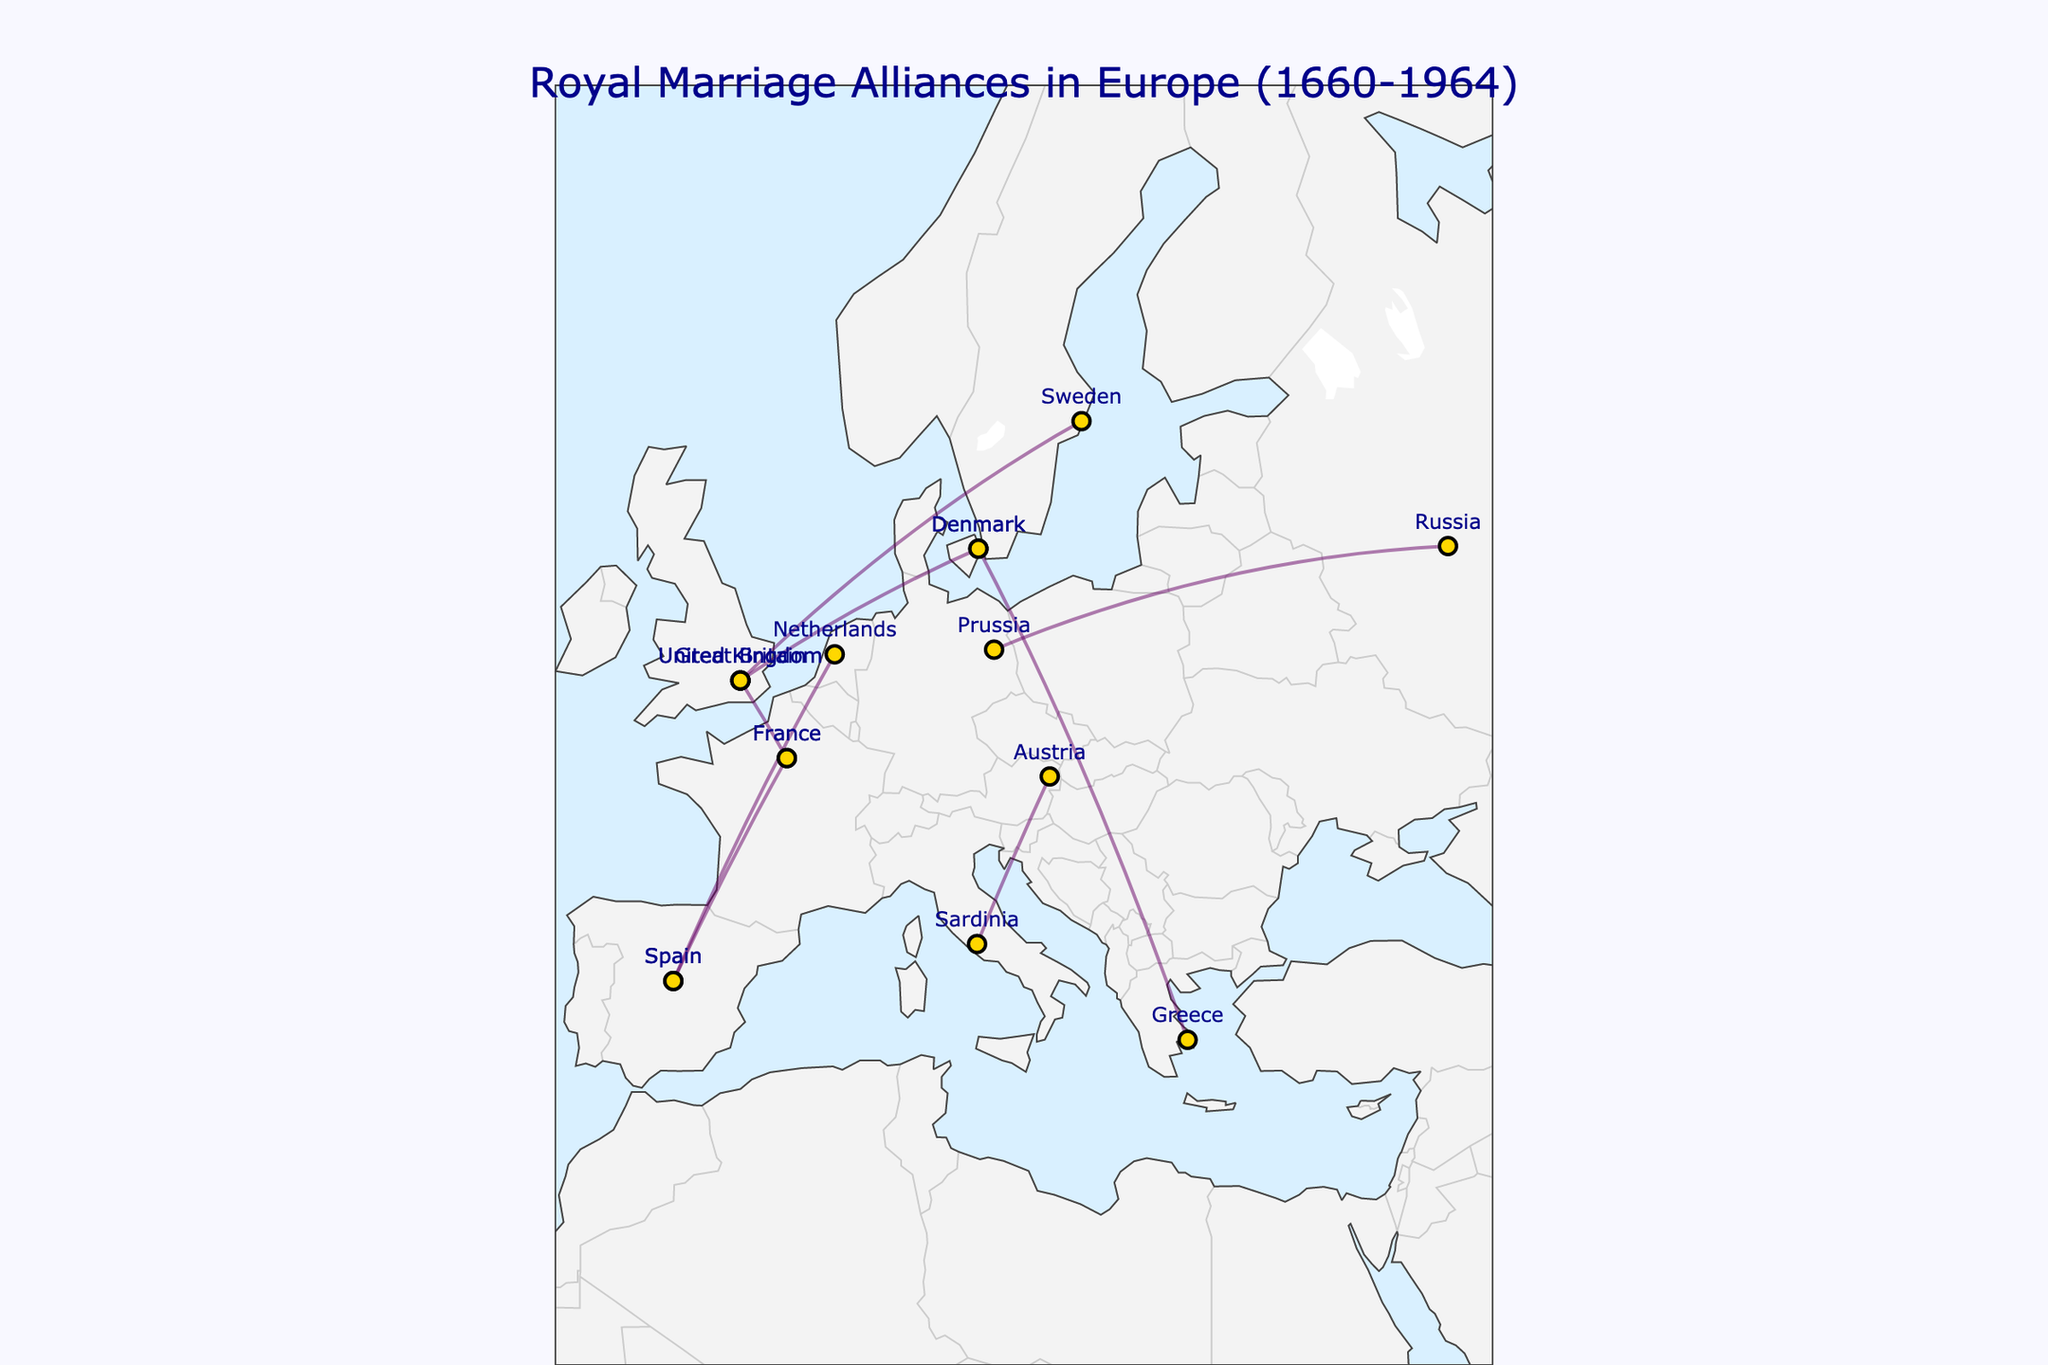What is the title of the plot? The title can be found at the top of the plot, usually in large font and centered.
Answer: Royal Marriage Alliances in Europe (1660-1964) What is the color of the lines representing royal marriages? The color of the lines can be seen by looking at the paths connecting different points on the plot.
Answer: Purple Which two dynasties were connected by a marriage in 1766? Look for the hover text or the lines indicating the marriages.
Answer: Hanover and Oldenburg Which country has the highest number of royal marriage connections represented in this plot? Count how many times each country appears in the plot.
Answer: United Kingdom What is the latitude and longitude range displayed on the plot? Check the labels on the axes or the bounding box of the plot's geographic area.
Answer: Latitude: 30 to 70, Longitude: -10 to 40 Which royal marriage is represented between dynasties from Sweden and the United Kingdom? Look for the line connecting the locations of Sweden and the United Kingdom and verify the hover text.
Answer: Bernadotte and Battenberg How many royal marriages involved France as one of the countries? Count the number of lines that have one endpoint in France (look at the hover text for 'France').
Answer: 2 Which marriage alliance is the most recent according to the plot? Look at the years listed and find the highest value. Hover over the corresponding line for details.
Answer: Bourbon-Parma and Orange-Nassau (1964) What ocean color is shown on the map? Observe the color used to represent the ocean in the geographic plot.
Answer: Light blue Which two countries are connected by a marriage represented by the line with the starting latitude near 41.9028 and longitude near 12.4964? Match the coordinates to the closest city and identify the line connected to it.
Answer: Sardinia (Italy) and Austria 